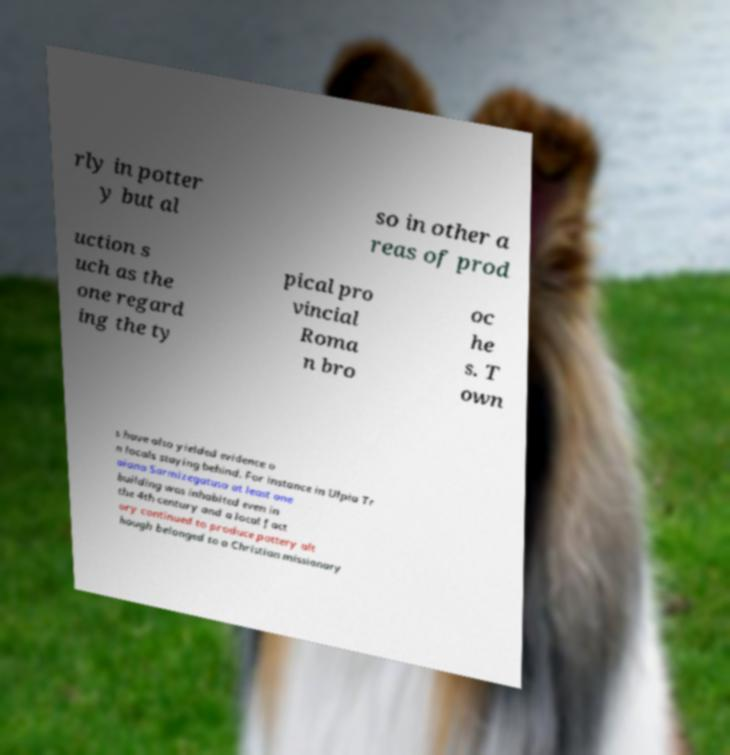Please identify and transcribe the text found in this image. rly in potter y but al so in other a reas of prod uction s uch as the one regard ing the ty pical pro vincial Roma n bro oc he s. T own s have also yielded evidence o n locals staying behind. For instance in Ulpia Tr aiana Sarmizegatusa at least one building was inhabited even in the 4th century and a local fact ory continued to produce pottery alt hough belonged to a Christian missionary 